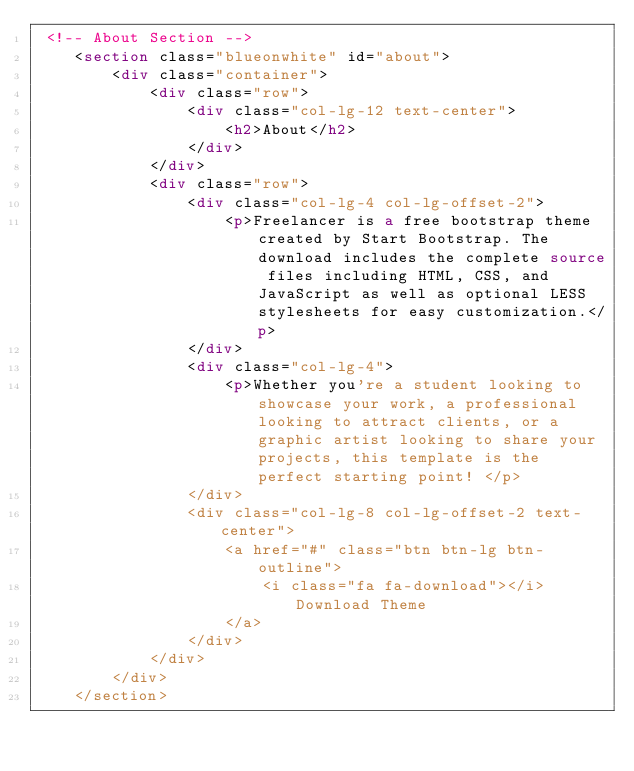<code> <loc_0><loc_0><loc_500><loc_500><_HTML_> <!-- About Section -->
    <section class="blueonwhite" id="about">
        <div class="container">
            <div class="row">
                <div class="col-lg-12 text-center">
                    <h2>About</h2>
                </div>
            </div>
            <div class="row">
                <div class="col-lg-4 col-lg-offset-2">
                    <p>Freelancer is a free bootstrap theme created by Start Bootstrap. The download includes the complete source files including HTML, CSS, and JavaScript as well as optional LESS stylesheets for easy customization.</p>
                </div>
                <div class="col-lg-4">
                    <p>Whether you're a student looking to showcase your work, a professional looking to attract clients, or a graphic artist looking to share your projects, this template is the perfect starting point! </p>
                </div>
                <div class="col-lg-8 col-lg-offset-2 text-center">
                    <a href="#" class="btn btn-lg btn-outline">
                        <i class="fa fa-download"></i> Download Theme
                    </a>
                </div>
            </div>
        </div>
    </section>
</code> 